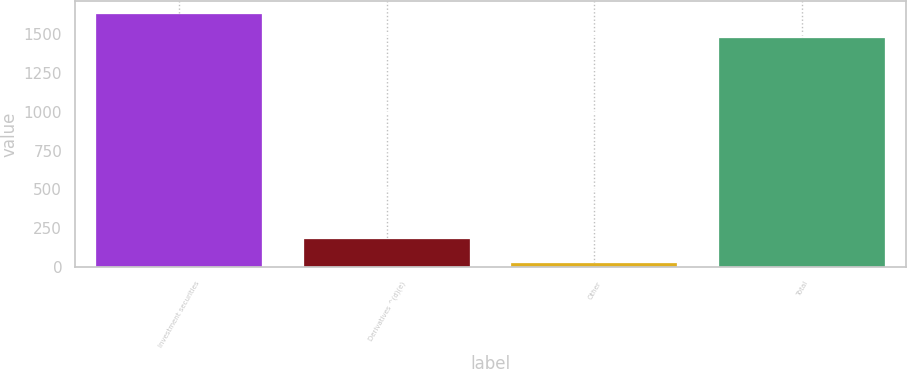<chart> <loc_0><loc_0><loc_500><loc_500><bar_chart><fcel>Investment securities<fcel>Derivatives ^(d)(e)<fcel>Other<fcel>Total<nl><fcel>1629.7<fcel>184.7<fcel>29<fcel>1474<nl></chart> 